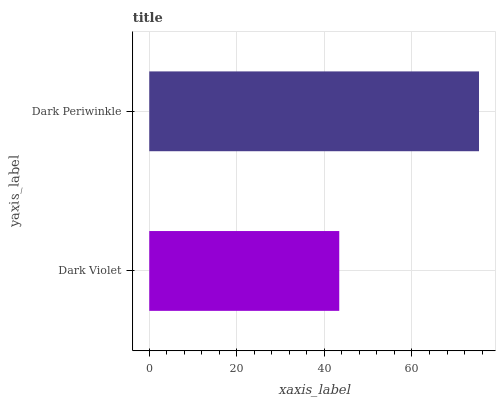Is Dark Violet the minimum?
Answer yes or no. Yes. Is Dark Periwinkle the maximum?
Answer yes or no. Yes. Is Dark Periwinkle the minimum?
Answer yes or no. No. Is Dark Periwinkle greater than Dark Violet?
Answer yes or no. Yes. Is Dark Violet less than Dark Periwinkle?
Answer yes or no. Yes. Is Dark Violet greater than Dark Periwinkle?
Answer yes or no. No. Is Dark Periwinkle less than Dark Violet?
Answer yes or no. No. Is Dark Periwinkle the high median?
Answer yes or no. Yes. Is Dark Violet the low median?
Answer yes or no. Yes. Is Dark Violet the high median?
Answer yes or no. No. Is Dark Periwinkle the low median?
Answer yes or no. No. 